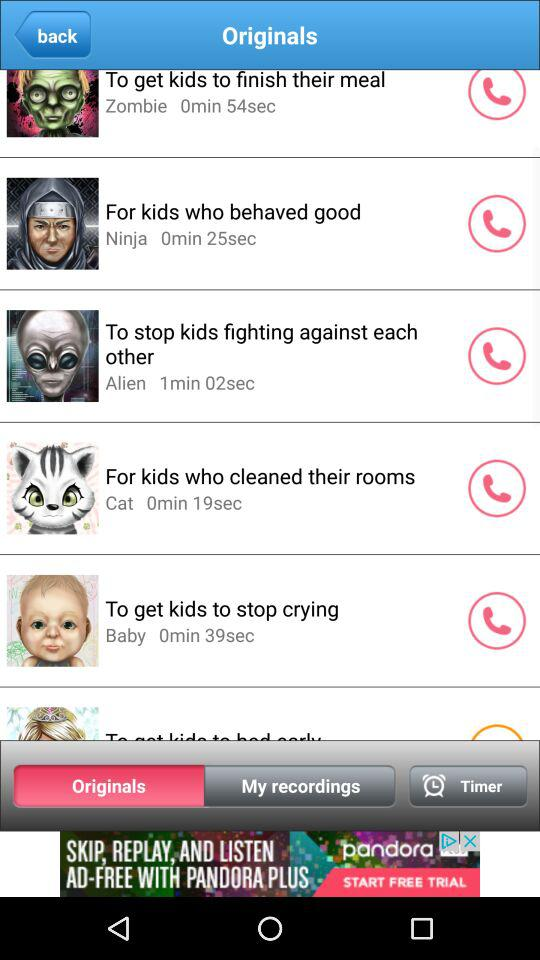Which tab is selected? The selected tab is "Originals". 